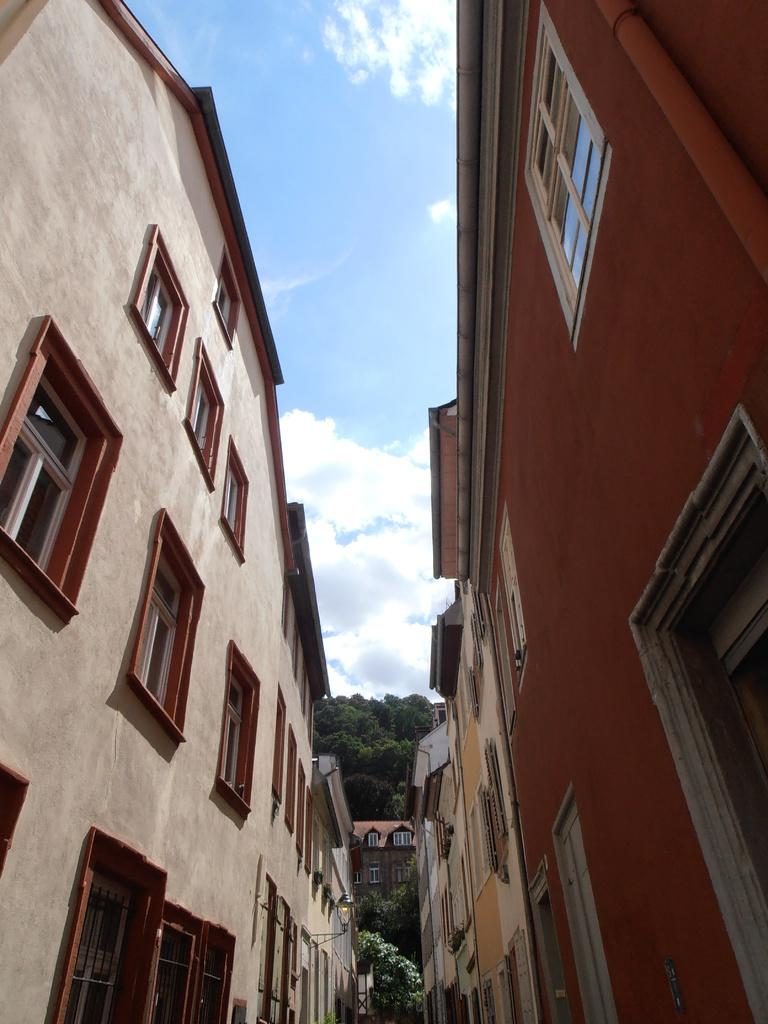What is located on the left side of the image? There are buildings on the left side of the image. What is located on the right side of the image? There are buildings on the right side of the image. What type of vegetation can be seen in the background of the image? There are trees in the background of the image. What is visible in the background of the image? The sky is visible in the background of the image. What type of whip can be seen in the image? There is no whip present in the image. Who is the governor in the image? There is no mention of a governor or any political figure in the image. 